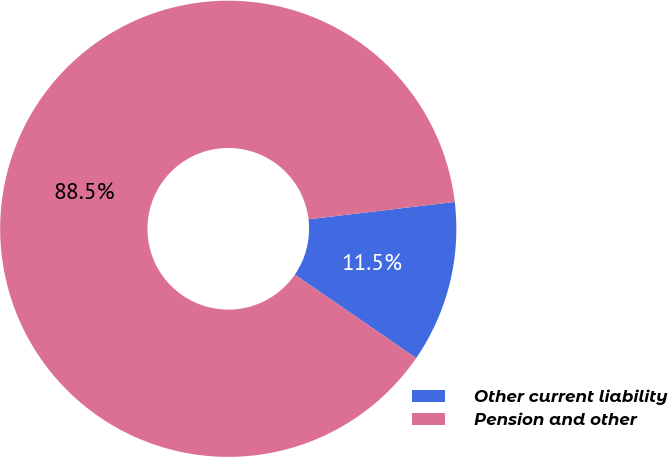Convert chart to OTSL. <chart><loc_0><loc_0><loc_500><loc_500><pie_chart><fcel>Other current liability<fcel>Pension and other<nl><fcel>11.47%<fcel>88.53%<nl></chart> 